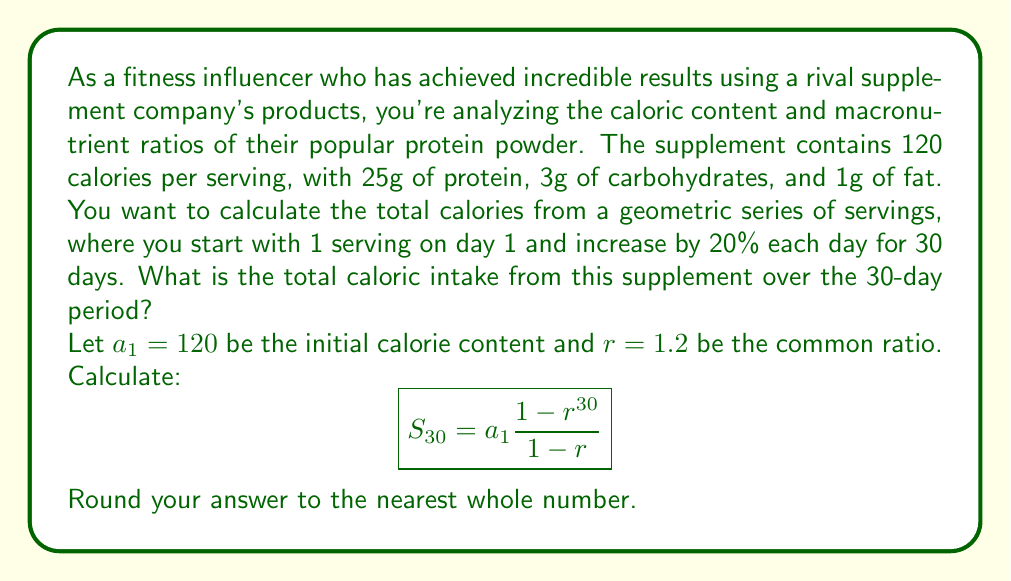Provide a solution to this math problem. To solve this problem, we'll use the formula for the sum of a geometric series:

$$S_n = a_1 \frac{1-r^n}{1-r}$$

Where:
$S_n$ is the sum of the series
$a_1$ is the first term
$r$ is the common ratio
$n$ is the number of terms

Given:
$a_1 = 120$ (calories in the first serving)
$r = 1.2$ (20% increase each day, so 1 + 0.2 = 1.2)
$n = 30$ (days)

Let's substitute these values into the formula:

$$S_{30} = 120 \frac{1-1.2^{30}}{1-1.2}$$

Now, let's calculate step by step:

1) First, calculate $1.2^{30}$:
   $1.2^{30} \approx 237.3760$

2) Now, calculate the numerator:
   $1 - 1.2^{30} \approx 1 - 237.3760 = -236.3760$

3) Calculate the denominator:
   $1 - 1.2 = -0.2$

4) Divide the numerator by the denominator:
   $\frac{-236.3760}{-0.2} = 1181.8800$

5) Multiply by $a_1 (120)$:
   $120 * 1181.8800 = 141,825.60$

6) Round to the nearest whole number:
   $141,826$

Therefore, the total caloric intake from the supplement over the 30-day period is approximately 141,826 calories.
Answer: 141,826 calories 